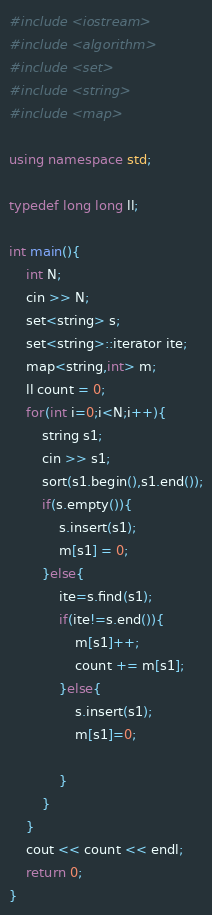Convert code to text. <code><loc_0><loc_0><loc_500><loc_500><_C++_>#include <iostream>
#include <algorithm>
#include <set>
#include <string>
#include <map>

using namespace std;

typedef long long ll;

int main(){
    int N;
    cin >> N;
    set<string> s;
    set<string>::iterator ite;
    map<string,int> m;
    ll count = 0;
    for(int i=0;i<N;i++){
        string s1;
        cin >> s1;
        sort(s1.begin(),s1.end());
        if(s.empty()){
            s.insert(s1);
            m[s1] = 0;
        }else{
            ite=s.find(s1);
            if(ite!=s.end()){
                m[s1]++;
                count += m[s1];
            }else{
                s.insert(s1);
                m[s1]=0;
                
            }
        }
    }
    cout << count << endl;
    return 0;
}
</code> 